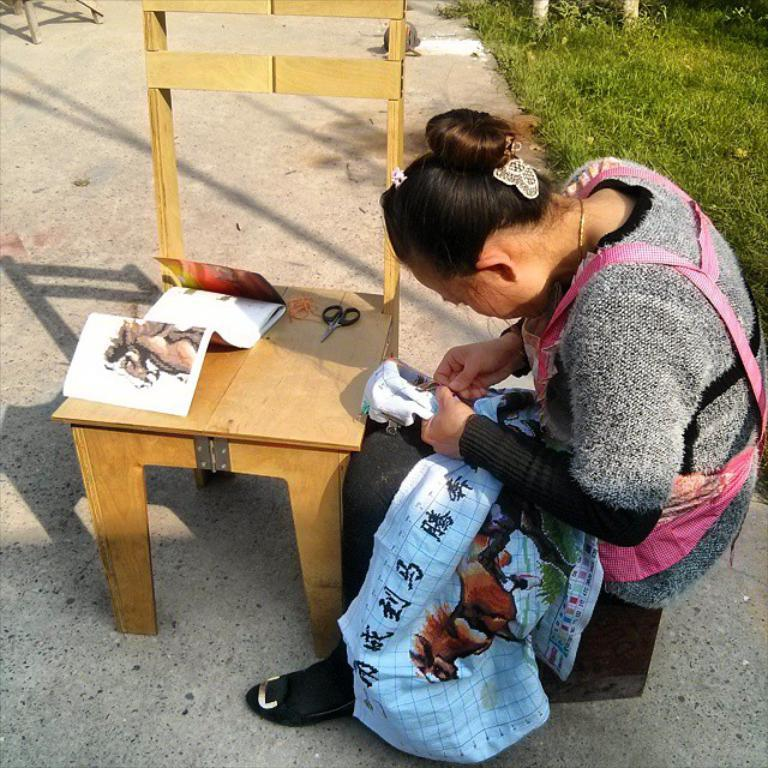What is located in the center of the picture? There is a chair, a pair of scissors, a book, and a woman stitching in the center of the picture. What is the woman doing in the center of the picture? The woman is stitching in the center of the picture. What can be seen on the right side of the picture? There are plants and grass on the right side of the picture. What is the weather like on the day the picture was taken? It is a sunny day. What type of range can be seen in the picture? There is no range present in the picture. What does the woman offer to the person on the left side of the picture? There is no person on the left side of the picture, and the woman is not offering anything. What type of sidewalk is visible in the picture? There is no sidewalk present in the picture. 